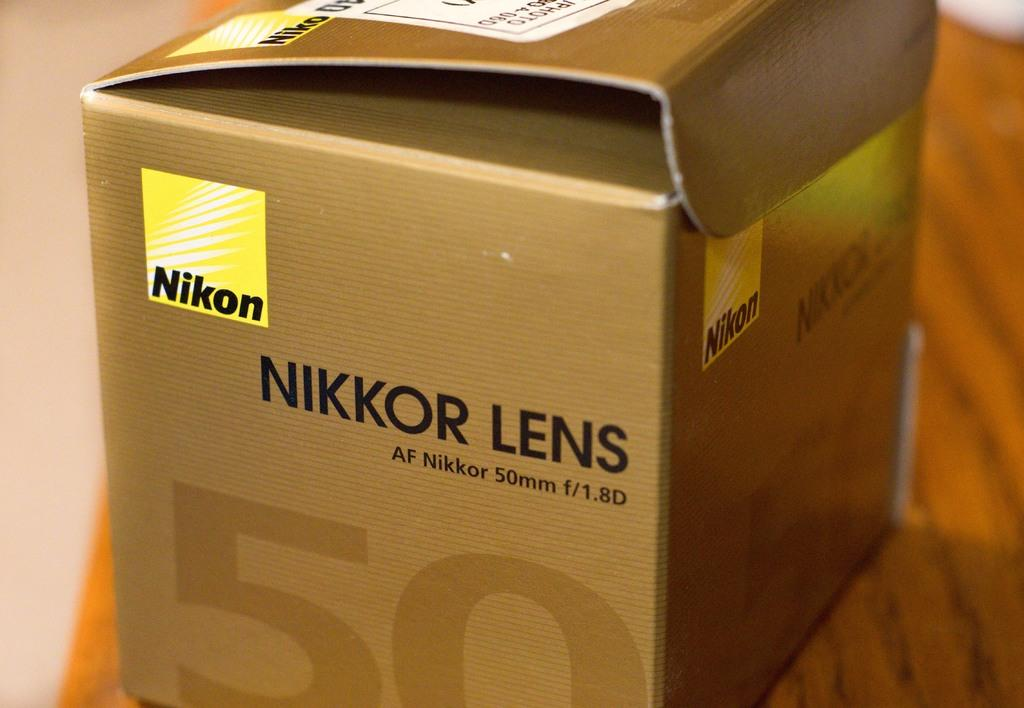<image>
Summarize the visual content of the image. A cardboard box which has or has had a Nikkpr Lens inside - AF Nikkor 50mm f/1.8D. 